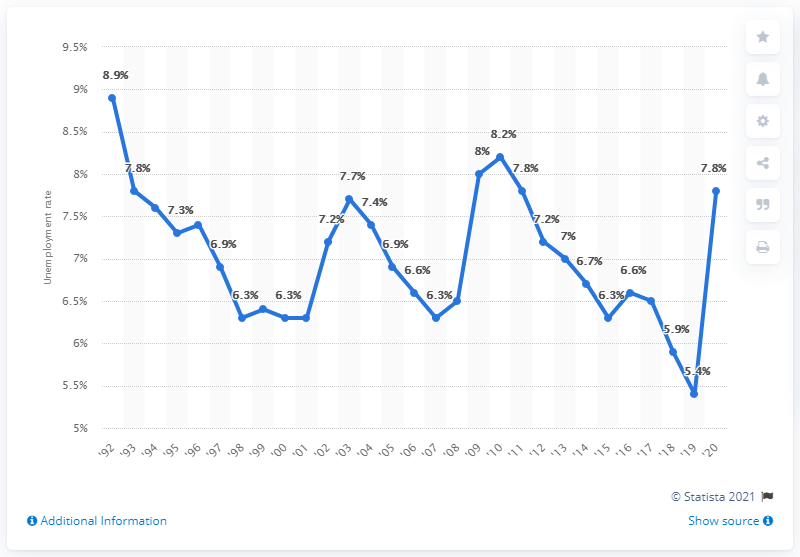What might have caused the sharp decrease in unemployment in 2020? While the graph does not specify causes, the sharp decrease in unemployment in 2020 could be related to economic changes or interventions, like stimulus packages or other government actions in response to significant events such as the COVID-19 pandemic, which affected job markets globally. 